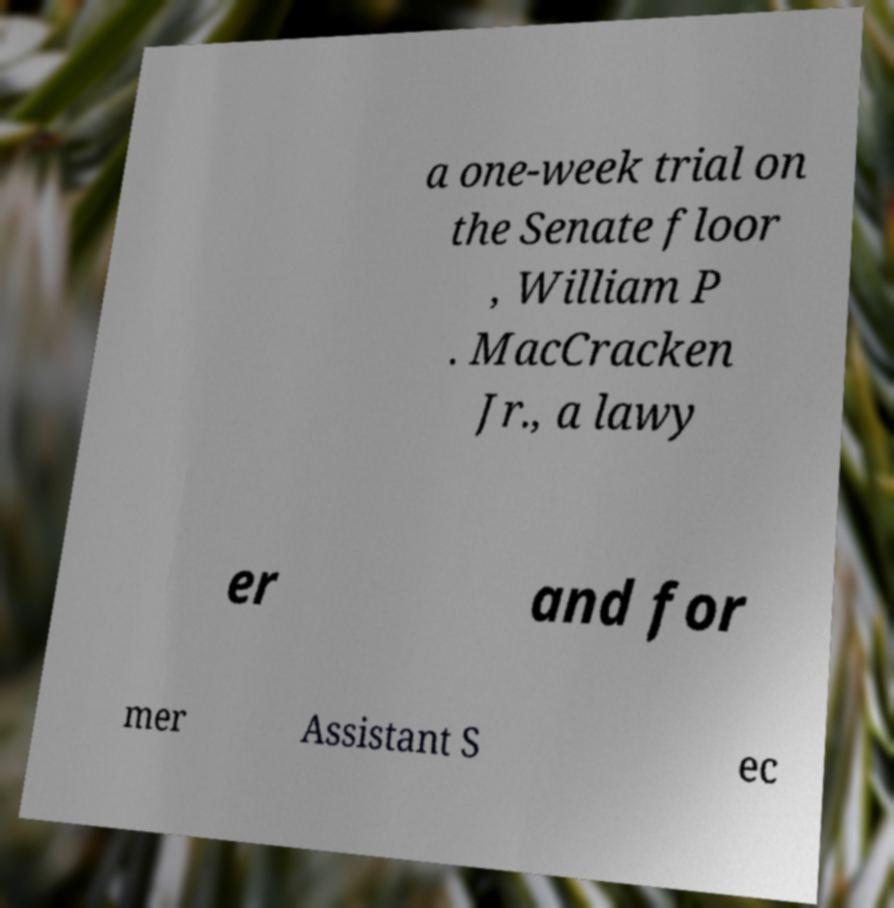What messages or text are displayed in this image? I need them in a readable, typed format. a one-week trial on the Senate floor , William P . MacCracken Jr., a lawy er and for mer Assistant S ec 